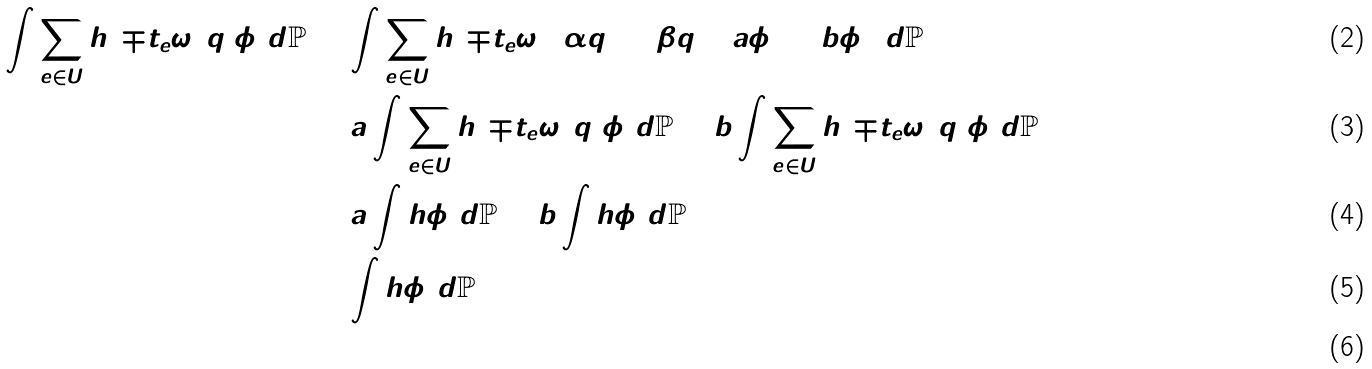Convert formula to latex. <formula><loc_0><loc_0><loc_500><loc_500>\int \sum _ { e \in U } h ( \mp t _ { e } \omega ) q _ { 3 } \phi _ { 3 } d \mathbb { P } & = \int \sum _ { e \in U } h ( \mp t _ { e } \omega ) ( \alpha q _ { 1 } + \beta q _ { 2 } ) ( a \phi _ { 1 } + b \phi _ { 2 } ) d \mathbb { P } \\ & = a \int \sum _ { e \in U } h ( \mp t _ { e } \omega ) q _ { 1 } \phi _ { 1 } d \mathbb { P } + b \int \sum _ { e \in U } h ( \mp t _ { e } \omega ) q _ { 2 } \phi _ { 2 } d \mathbb { P } \\ & = a \int h \phi _ { 1 } d \mathbb { P } + b \int h \phi _ { 2 } d \mathbb { P } \\ & = \int h \phi _ { 3 } d \mathbb { P } \\</formula> 